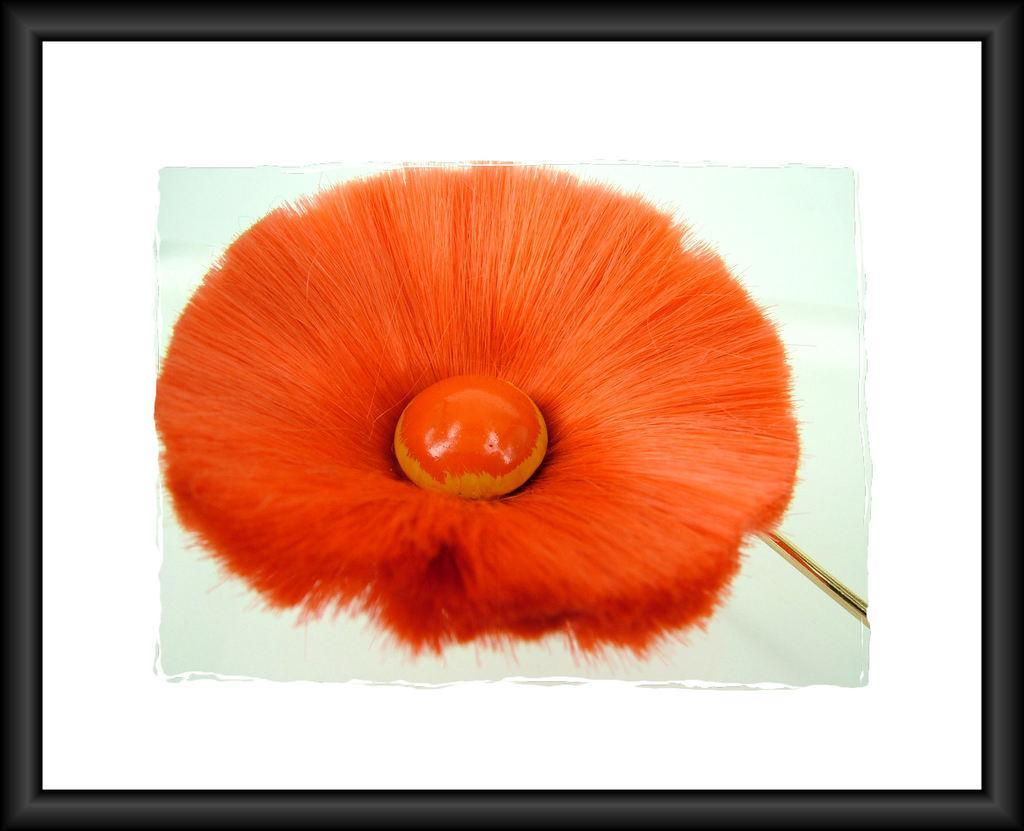How would you summarize this image in a sentence or two? In this image I can see there is a frame and there is a brush fossil. 